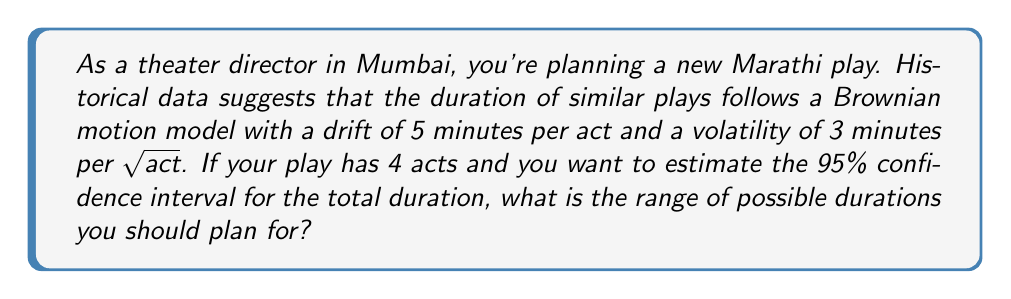Can you solve this math problem? Let's approach this step-by-step:

1) In Brownian motion, the duration $X_t$ at time $t$ (in this case, $t$ represents the number of acts) is normally distributed with:

   Mean: $\mu t$
   Variance: $\sigma^2 t$

   Where $\mu$ is the drift and $\sigma$ is the volatility.

2) Given:
   - Drift ($\mu$) = 5 minutes/act
   - Volatility ($\sigma$) = 3 minutes/sqrt(act)
   - Number of acts ($t$) = 4

3) Calculate the expected duration:
   $E[X_4] = \mu t = 5 \times 4 = 20$ minutes

4) Calculate the variance:
   $Var[X_4] = \sigma^2 t = 3^2 \times 4 = 36$ square minutes

5) The standard deviation is the square root of the variance:
   $SD[X_4] = \sqrt{36} = 6$ minutes

6) For a 95% confidence interval, we use 1.96 standard deviations on either side of the mean:

   Lower bound: $20 - (1.96 \times 6) = 8.24$ minutes
   Upper bound: $20 + (1.96 \times 6) = 31.76$ minutes

7) Rounding to the nearest minute for practical use:
   Range: 8 to 32 minutes
Answer: 8 to 32 minutes 